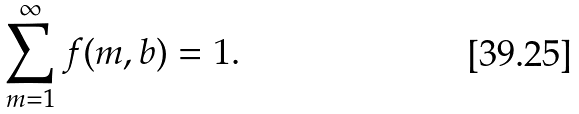<formula> <loc_0><loc_0><loc_500><loc_500>\sum _ { m = 1 } ^ { \infty } f ( m , b ) = 1 .</formula> 